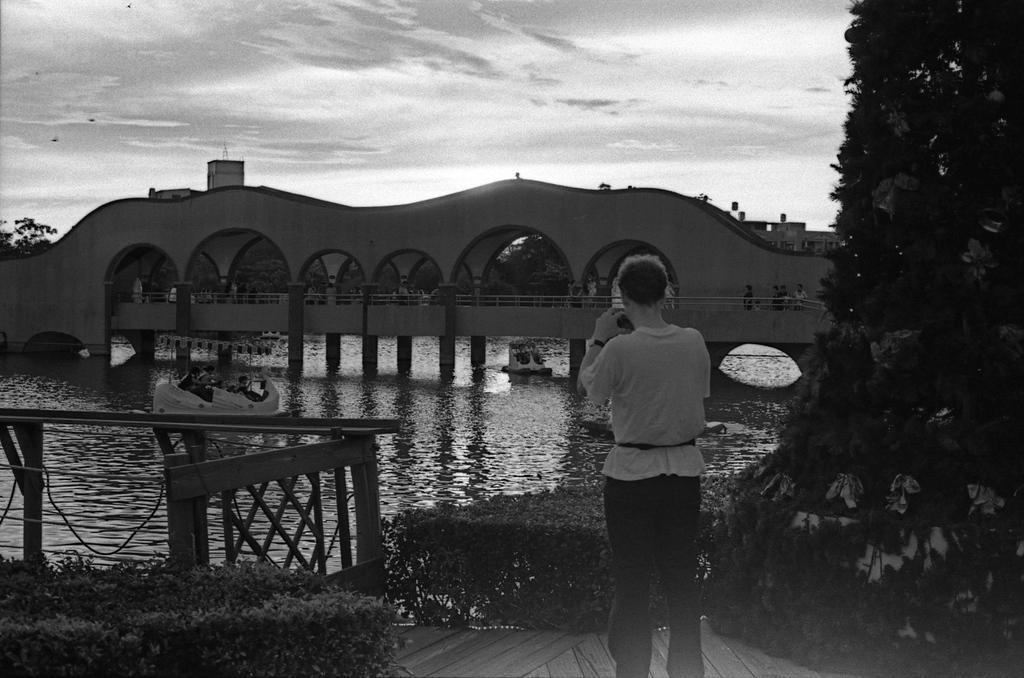Can you describe this image briefly? In this picture there is a woman who is holding a camera. In the back I can see the boats on the water, beside that I can see the bridge and some persons are crossing the bridge. At the bottom I can see the planets near to the fencing. At the top I can see the sky and clouds. On the right I can see the trees. In the top left corner I can see some birds which are flying. 